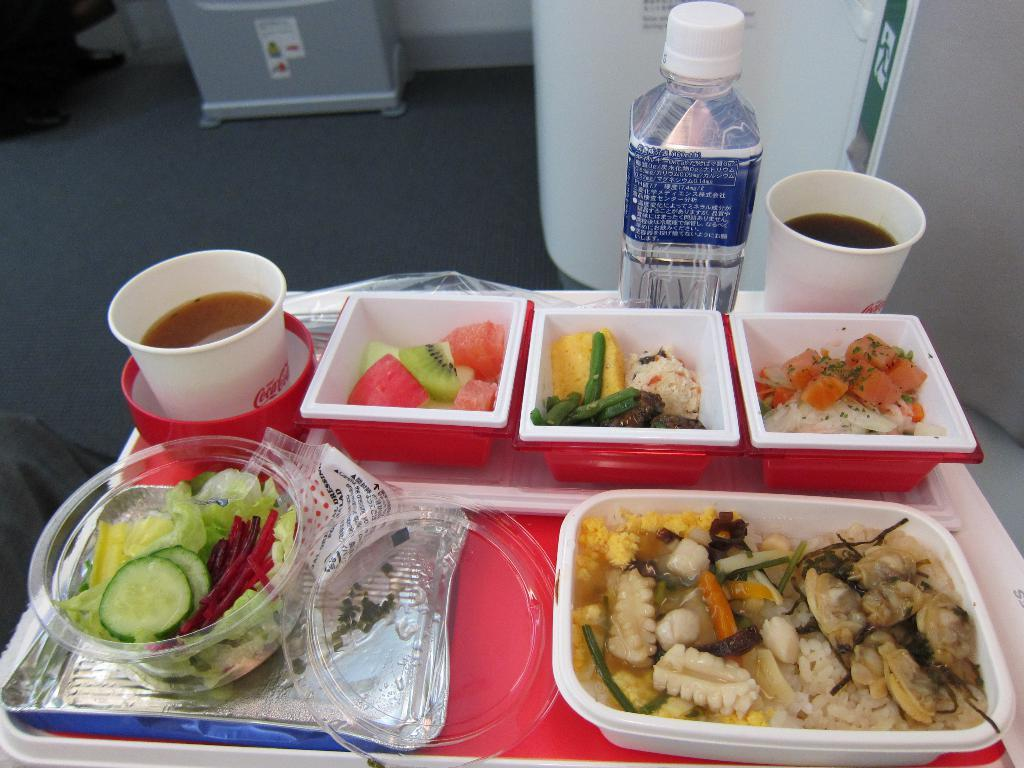What can be found on the table in the image? There are food items and a cup with a drink on the table. What else is on the table besides the cup? There is also a water bottle on the table. What is visible in the background of the image? The background of the image includes a floor. Can you tell me how many chess pieces are on the table in the image? There are no chess pieces present in the image; it only features food items, a cup with a drink, and a water bottle on the table. 